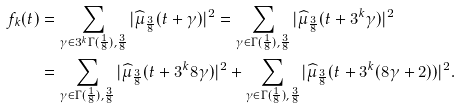<formula> <loc_0><loc_0><loc_500><loc_500>f _ { k } ( t ) & = \sum _ { \gamma \in 3 ^ { k } \Gamma ( \frac { 1 } { 8 } ) , \frac { 3 } { 8 } } | \widehat { \mu } _ { \frac { 3 } { 8 } } ( t + \gamma ) | ^ { 2 } = \sum _ { \gamma \in \Gamma ( \frac { 1 } { 8 } ) , \frac { 3 } { 8 } } | \widehat { \mu } _ { \frac { 3 } { 8 } } ( t + 3 ^ { k } \gamma ) | ^ { 2 } \\ & = \sum _ { \gamma \in \Gamma ( \frac { 1 } { 8 } ) , \frac { 3 } { 8 } } | \widehat { \mu } _ { \frac { 3 } { 8 } } ( t + 3 ^ { k } 8 \gamma ) | ^ { 2 } + \sum _ { \gamma \in \Gamma ( \frac { 1 } { 8 } ) , \frac { 3 } { 8 } } | \widehat { \mu } _ { \frac { 3 } { 8 } } ( t + 3 ^ { k } ( 8 \gamma + 2 ) ) | ^ { 2 } . \\</formula> 